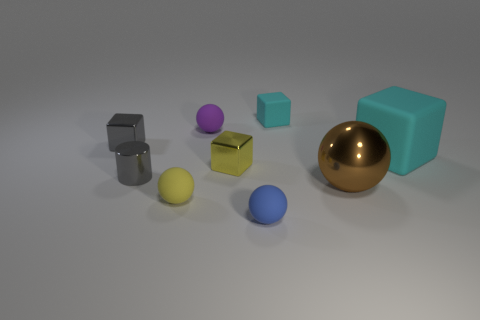Subtract all small purple rubber spheres. How many spheres are left? 3 Subtract all brown balls. How many balls are left? 3 Subtract 2 blocks. How many blocks are left? 2 Add 1 yellow blocks. How many objects exist? 10 Subtract all cubes. How many objects are left? 5 Subtract all purple cylinders. How many purple blocks are left? 0 Subtract all yellow spheres. Subtract all small gray blocks. How many objects are left? 7 Add 7 small cyan blocks. How many small cyan blocks are left? 8 Add 4 metallic cubes. How many metallic cubes exist? 6 Subtract 1 yellow spheres. How many objects are left? 8 